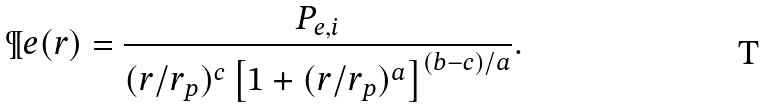<formula> <loc_0><loc_0><loc_500><loc_500>\P e ( r ) = \frac { P _ { e , i } } { ( r / r _ { p } ) ^ { c } \left [ 1 + ( r / r _ { p } ) ^ { a } \right ] ^ { ( b - c ) / a } } .</formula> 